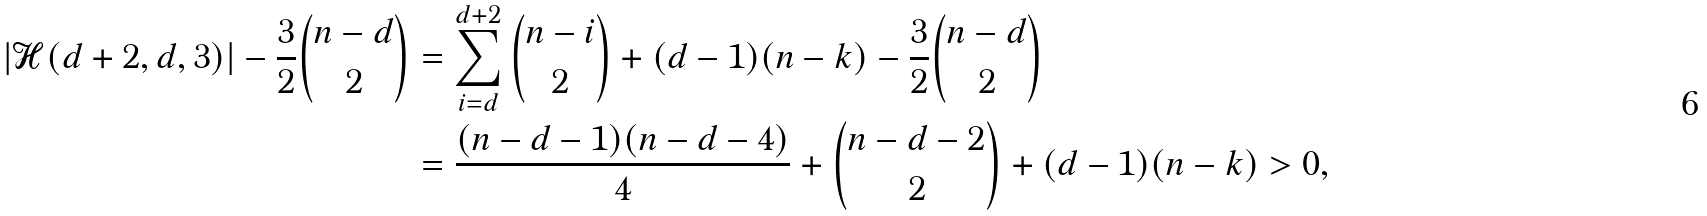Convert formula to latex. <formula><loc_0><loc_0><loc_500><loc_500>| \mathcal { H } ( d + 2 , d , 3 ) | - \frac { 3 } { 2 } \binom { n - d } { 2 } & = \sum _ { i = d } ^ { d + 2 } \binom { n - i } { 2 } + ( d - 1 ) ( n - k ) - \frac { 3 } { 2 } \binom { n - d } { 2 } \\ & = \frac { ( n - d - 1 ) ( n - d - 4 ) } { 4 } + \binom { n - d - 2 } { 2 } + ( d - 1 ) ( n - k ) > 0 ,</formula> 